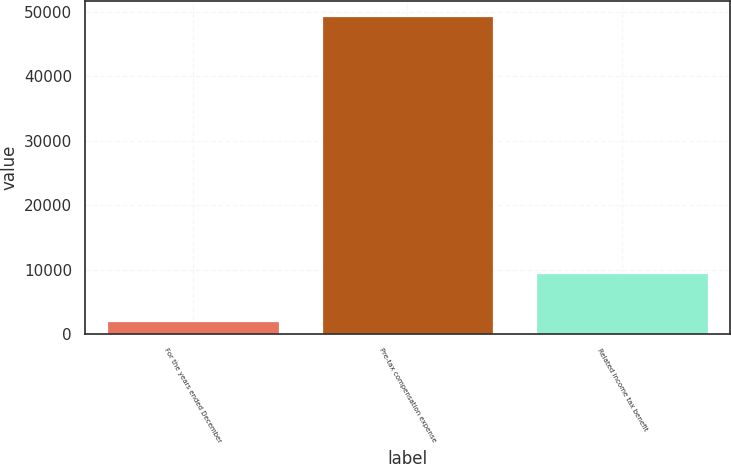<chart> <loc_0><loc_0><loc_500><loc_500><bar_chart><fcel>For the years ended December<fcel>Pre-tax compensation expense<fcel>Related income tax benefit<nl><fcel>2018<fcel>49286<fcel>9463<nl></chart> 